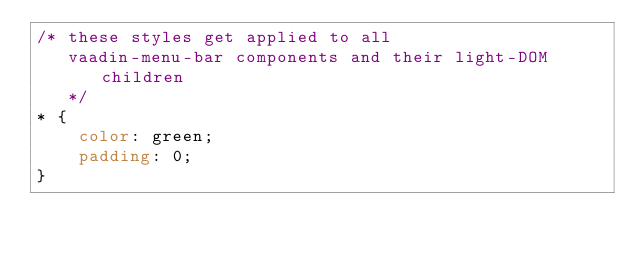Convert code to text. <code><loc_0><loc_0><loc_500><loc_500><_CSS_>/* these styles get applied to all
   vaadin-menu-bar components and their light-DOM children
   */
* {
    color: green;
    padding: 0;
}</code> 